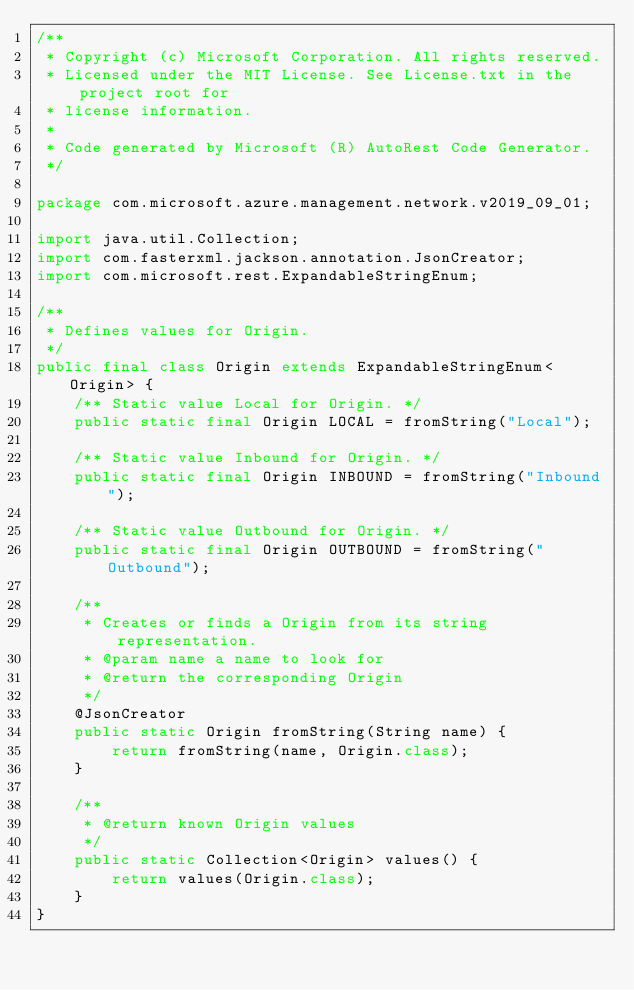Convert code to text. <code><loc_0><loc_0><loc_500><loc_500><_Java_>/**
 * Copyright (c) Microsoft Corporation. All rights reserved.
 * Licensed under the MIT License. See License.txt in the project root for
 * license information.
 *
 * Code generated by Microsoft (R) AutoRest Code Generator.
 */

package com.microsoft.azure.management.network.v2019_09_01;

import java.util.Collection;
import com.fasterxml.jackson.annotation.JsonCreator;
import com.microsoft.rest.ExpandableStringEnum;

/**
 * Defines values for Origin.
 */
public final class Origin extends ExpandableStringEnum<Origin> {
    /** Static value Local for Origin. */
    public static final Origin LOCAL = fromString("Local");

    /** Static value Inbound for Origin. */
    public static final Origin INBOUND = fromString("Inbound");

    /** Static value Outbound for Origin. */
    public static final Origin OUTBOUND = fromString("Outbound");

    /**
     * Creates or finds a Origin from its string representation.
     * @param name a name to look for
     * @return the corresponding Origin
     */
    @JsonCreator
    public static Origin fromString(String name) {
        return fromString(name, Origin.class);
    }

    /**
     * @return known Origin values
     */
    public static Collection<Origin> values() {
        return values(Origin.class);
    }
}
</code> 